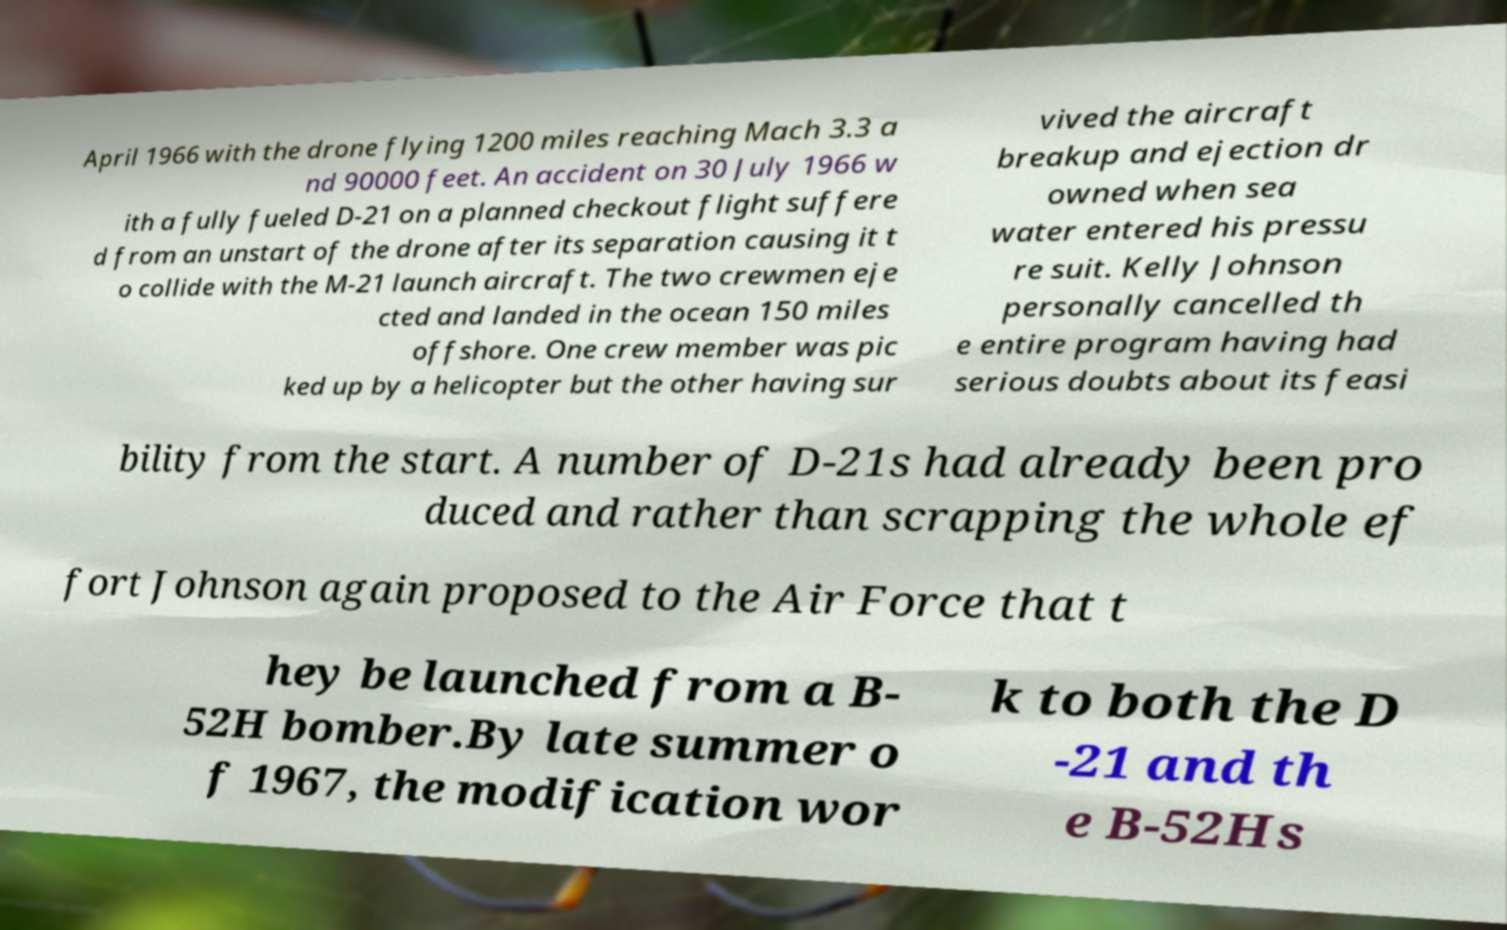There's text embedded in this image that I need extracted. Can you transcribe it verbatim? April 1966 with the drone flying 1200 miles reaching Mach 3.3 a nd 90000 feet. An accident on 30 July 1966 w ith a fully fueled D-21 on a planned checkout flight suffere d from an unstart of the drone after its separation causing it t o collide with the M-21 launch aircraft. The two crewmen eje cted and landed in the ocean 150 miles offshore. One crew member was pic ked up by a helicopter but the other having sur vived the aircraft breakup and ejection dr owned when sea water entered his pressu re suit. Kelly Johnson personally cancelled th e entire program having had serious doubts about its feasi bility from the start. A number of D-21s had already been pro duced and rather than scrapping the whole ef fort Johnson again proposed to the Air Force that t hey be launched from a B- 52H bomber.By late summer o f 1967, the modification wor k to both the D -21 and th e B-52Hs 